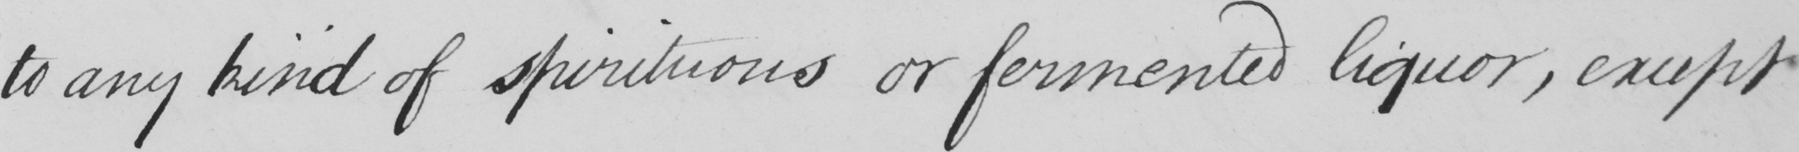Can you read and transcribe this handwriting? to any kind of spirituous or fermented liquor, except 